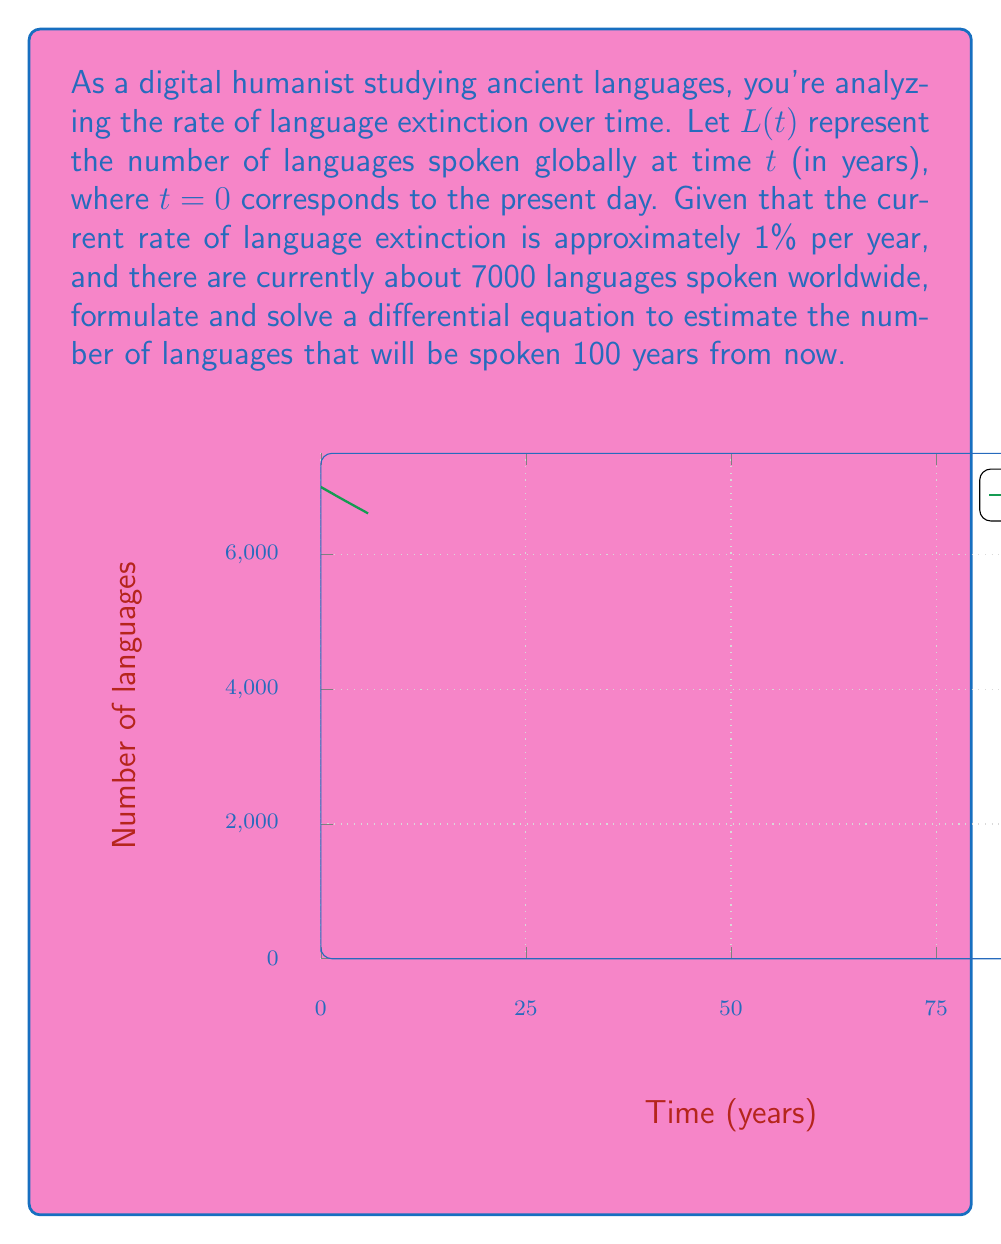What is the answer to this math problem? Let's approach this step-by-step:

1) We're given that the rate of language extinction is 1% per year. This means that the rate of change of $L(t)$ is proportional to $L(t)$ itself, with a proportionality constant of -0.01 (negative because languages are becoming extinct). We can express this as a differential equation:

   $$\frac{dL}{dt} = -0.01L$$

2) This is a first-order linear differential equation. The general solution to this type of equation is:

   $$L(t) = Ce^{-0.01t}$$

   where $C$ is a constant we need to determine.

3) We're given the initial condition: at $t=0$ (present day), there are 7000 languages. Let's use this to find $C$:

   $$L(0) = Ce^{-0.01(0)} = C = 7000$$

4) So our specific solution is:

   $$L(t) = 7000e^{-0.01t}$$

5) To find the number of languages 100 years from now, we evaluate $L(100)$:

   $$L(100) = 7000e^{-0.01(100)} = 7000e^{-1} \approx 2575$$

Therefore, approximately 2575 languages will be spoken 100 years from now, according to this model.
Answer: $L(100) \approx 2575$ languages 